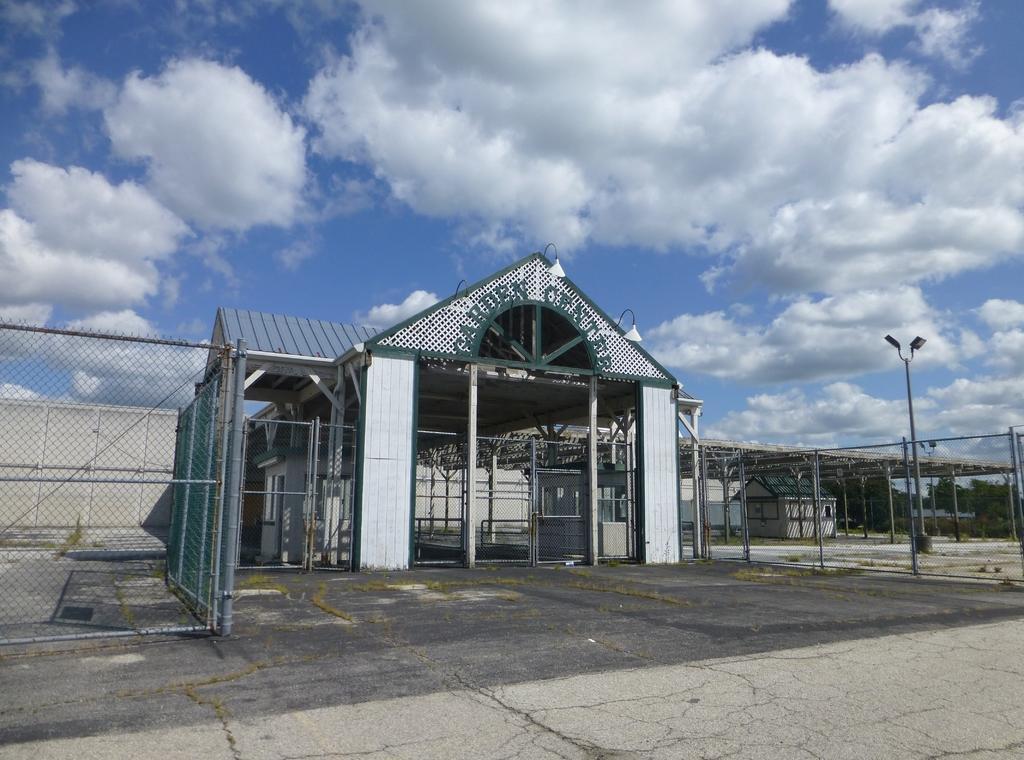Describe this image in one or two sentences. In this image there is a building with the name at the top, there is a small house under the shed, few fences, two lights to a pole, trees and some clouds in the sky. 